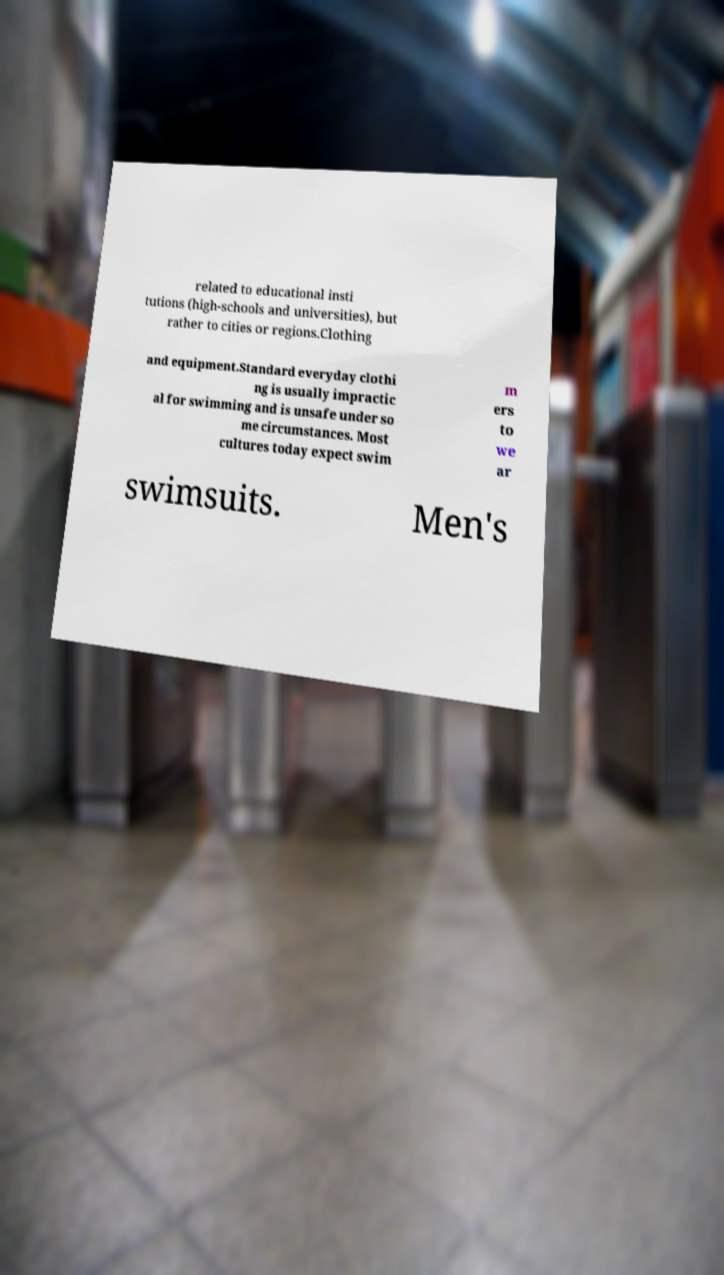What messages or text are displayed in this image? I need them in a readable, typed format. related to educational insti tutions (high-schools and universities), but rather to cities or regions.Clothing and equipment.Standard everyday clothi ng is usually impractic al for swimming and is unsafe under so me circumstances. Most cultures today expect swim m ers to we ar swimsuits. Men's 